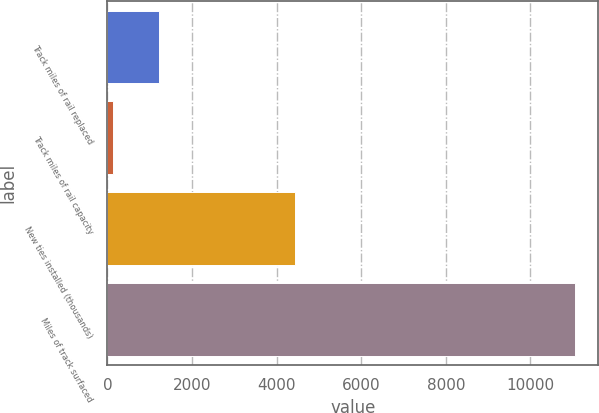Convert chart. <chart><loc_0><loc_0><loc_500><loc_500><bar_chart><fcel>Track miles of rail replaced<fcel>Track miles of rail capacity<fcel>New ties installed (thousands)<fcel>Miles of track surfaced<nl><fcel>1230<fcel>139<fcel>4436<fcel>11049<nl></chart> 